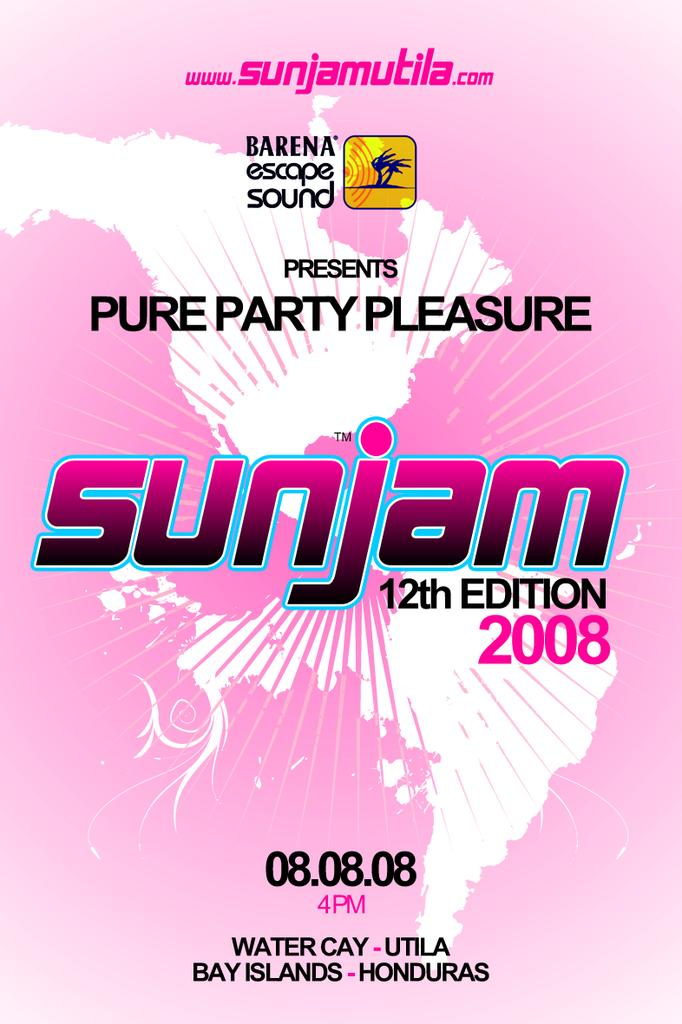<image>
Render a clear and concise summary of the photo. A pink poster says sunjam 12th edition 2008. 